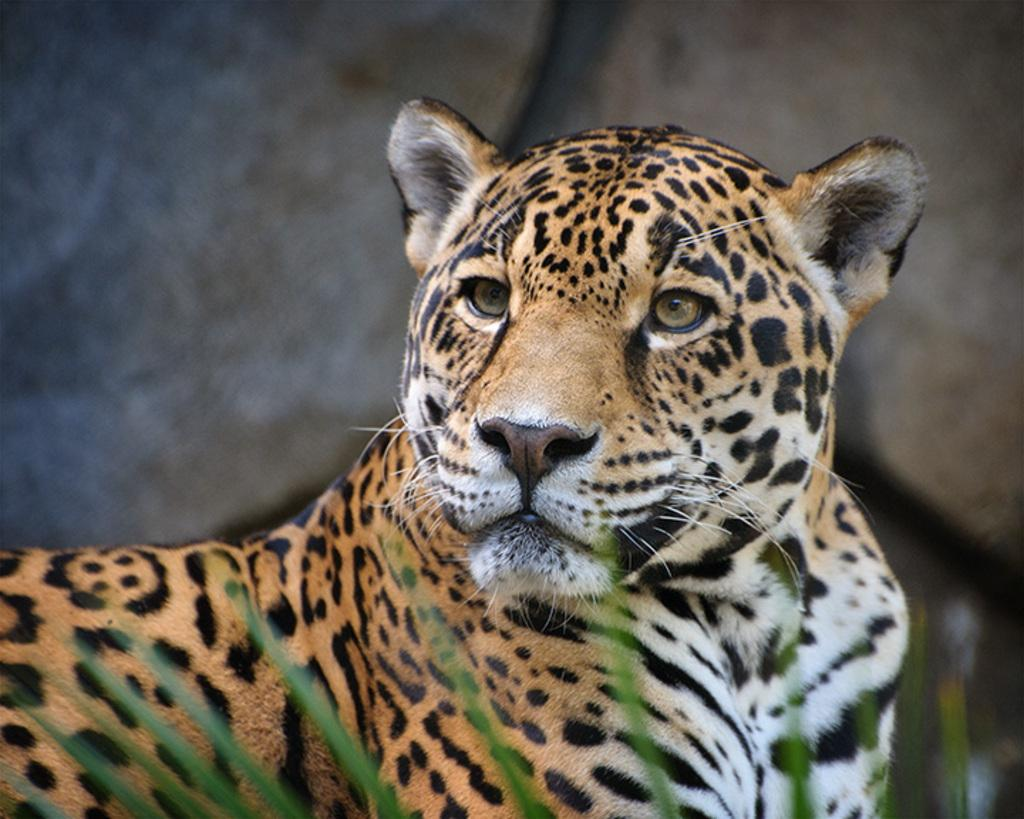What animal is the main subject of the image? There is a leopard in the image. What type of vegetation can be seen at the bottom of the image? There are leaves at the bottom of the image. Can you describe the background of the image? The background of the image is blurry. What type of record can be seen spinning on a plate in the image? There is no record or plate present in the image; it features a leopard and leaves. What season is depicted in the image, given the presence of spring flowers? There are no spring flowers mentioned in the image; it only mentions leaves. 